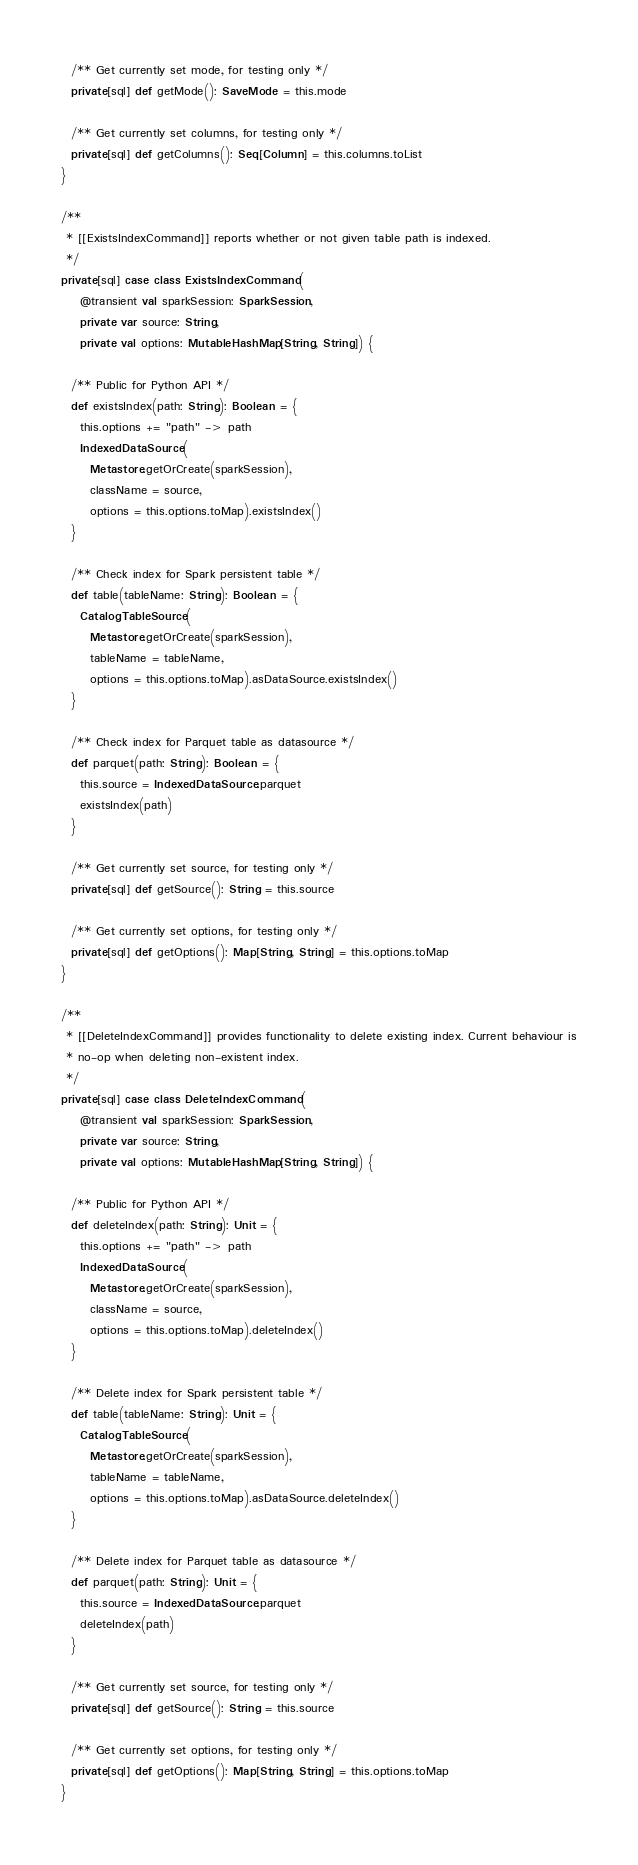<code> <loc_0><loc_0><loc_500><loc_500><_Scala_>  /** Get currently set mode, for testing only */
  private[sql] def getMode(): SaveMode = this.mode

  /** Get currently set columns, for testing only */
  private[sql] def getColumns(): Seq[Column] = this.columns.toList
}

/**
 * [[ExistsIndexCommand]] reports whether or not given table path is indexed.
 */
private[sql] case class ExistsIndexCommand(
    @transient val sparkSession: SparkSession,
    private var source: String,
    private val options: MutableHashMap[String, String]) {

  /** Public for Python API */
  def existsIndex(path: String): Boolean = {
    this.options += "path" -> path
    IndexedDataSource(
      Metastore.getOrCreate(sparkSession),
      className = source,
      options = this.options.toMap).existsIndex()
  }

  /** Check index for Spark persistent table */
  def table(tableName: String): Boolean = {
    CatalogTableSource(
      Metastore.getOrCreate(sparkSession),
      tableName = tableName,
      options = this.options.toMap).asDataSource.existsIndex()
  }

  /** Check index for Parquet table as datasource */
  def parquet(path: String): Boolean = {
    this.source = IndexedDataSource.parquet
    existsIndex(path)
  }

  /** Get currently set source, for testing only */
  private[sql] def getSource(): String = this.source

  /** Get currently set options, for testing only */
  private[sql] def getOptions(): Map[String, String] = this.options.toMap
}

/**
 * [[DeleteIndexCommand]] provides functionality to delete existing index. Current behaviour is
 * no-op when deleting non-existent index.
 */
private[sql] case class DeleteIndexCommand(
    @transient val sparkSession: SparkSession,
    private var source: String,
    private val options: MutableHashMap[String, String]) {

  /** Public for Python API */
  def deleteIndex(path: String): Unit = {
    this.options += "path" -> path
    IndexedDataSource(
      Metastore.getOrCreate(sparkSession),
      className = source,
      options = this.options.toMap).deleteIndex()
  }

  /** Delete index for Spark persistent table */
  def table(tableName: String): Unit = {
    CatalogTableSource(
      Metastore.getOrCreate(sparkSession),
      tableName = tableName,
      options = this.options.toMap).asDataSource.deleteIndex()
  }

  /** Delete index for Parquet table as datasource */
  def parquet(path: String): Unit = {
    this.source = IndexedDataSource.parquet
    deleteIndex(path)
  }

  /** Get currently set source, for testing only */
  private[sql] def getSource(): String = this.source

  /** Get currently set options, for testing only */
  private[sql] def getOptions(): Map[String, String] = this.options.toMap
}
</code> 